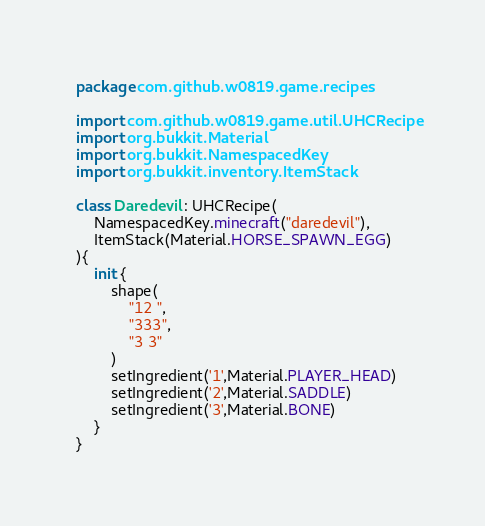<code> <loc_0><loc_0><loc_500><loc_500><_Kotlin_>package com.github.w0819.game.recipes

import com.github.w0819.game.util.UHCRecipe
import org.bukkit.Material
import org.bukkit.NamespacedKey
import org.bukkit.inventory.ItemStack

class Daredevil : UHCRecipe(
    NamespacedKey.minecraft("daredevil"),
    ItemStack(Material.HORSE_SPAWN_EGG)
){
    init {
        shape(
            "12 ",
            "333",
            "3 3"
        )
        setIngredient('1',Material.PLAYER_HEAD)
        setIngredient('2',Material.SADDLE)
        setIngredient('3',Material.BONE)
    }
}</code> 